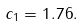Convert formula to latex. <formula><loc_0><loc_0><loc_500><loc_500>c _ { 1 } = 1 . 7 6 .</formula> 